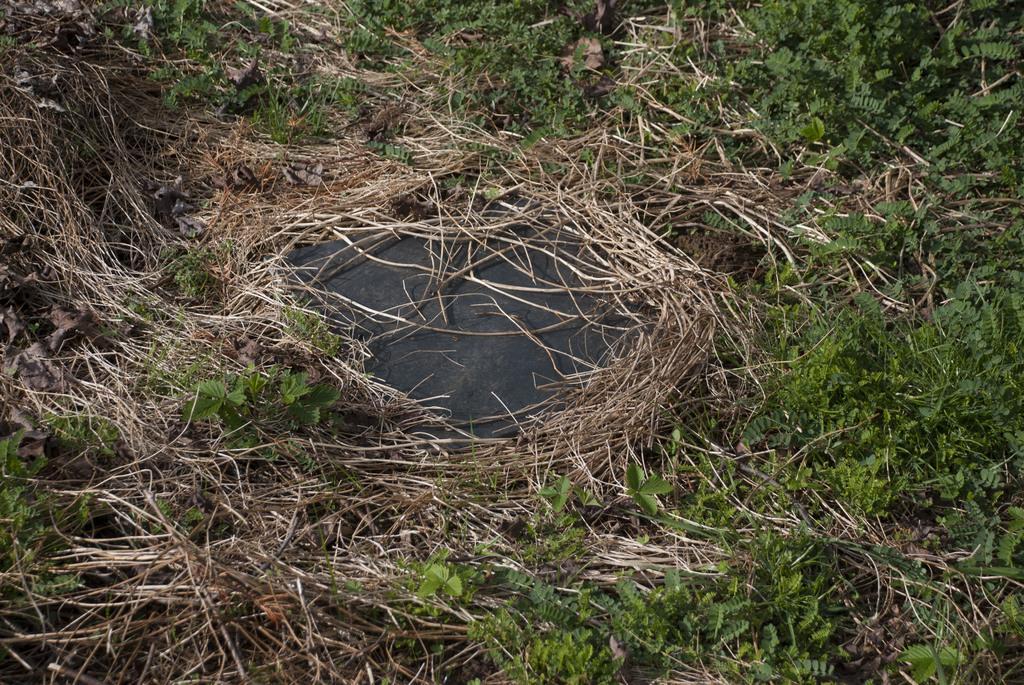Please provide a concise description of this image. In this image, we can see some plants and dry grass. 